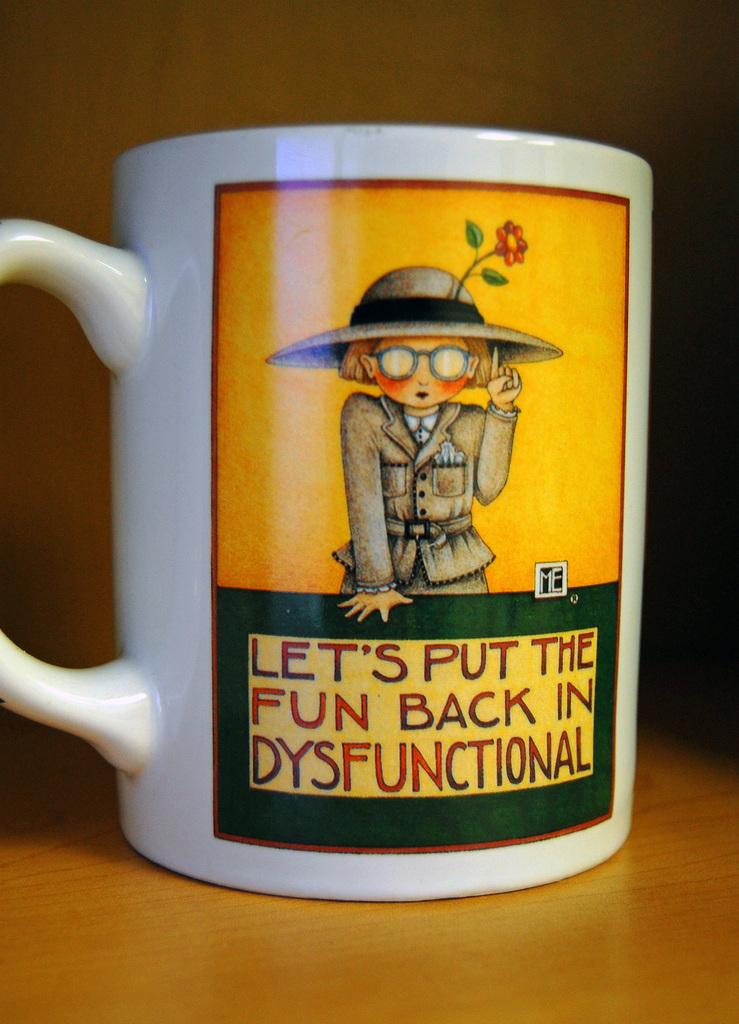<image>
Share a concise interpretation of the image provided. A mug that says Let's put the fun back in dysfunctional. 